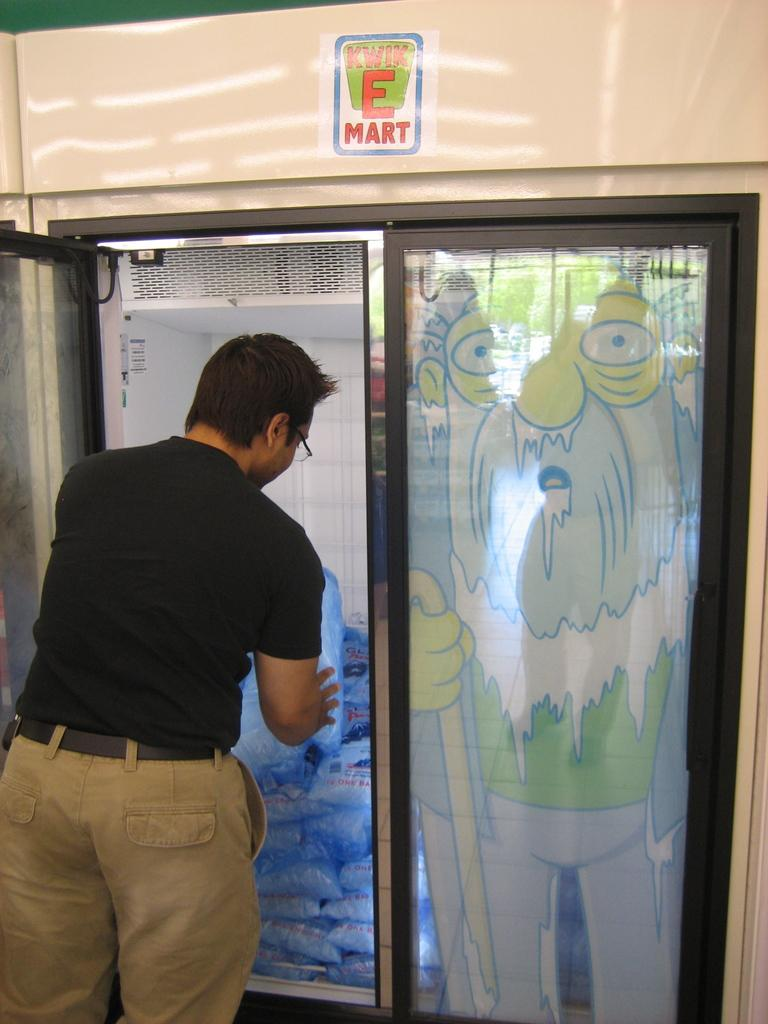Provide a one-sentence caption for the provided image. A man removes a bag of ice from a Kwik E Mart store freezer. 